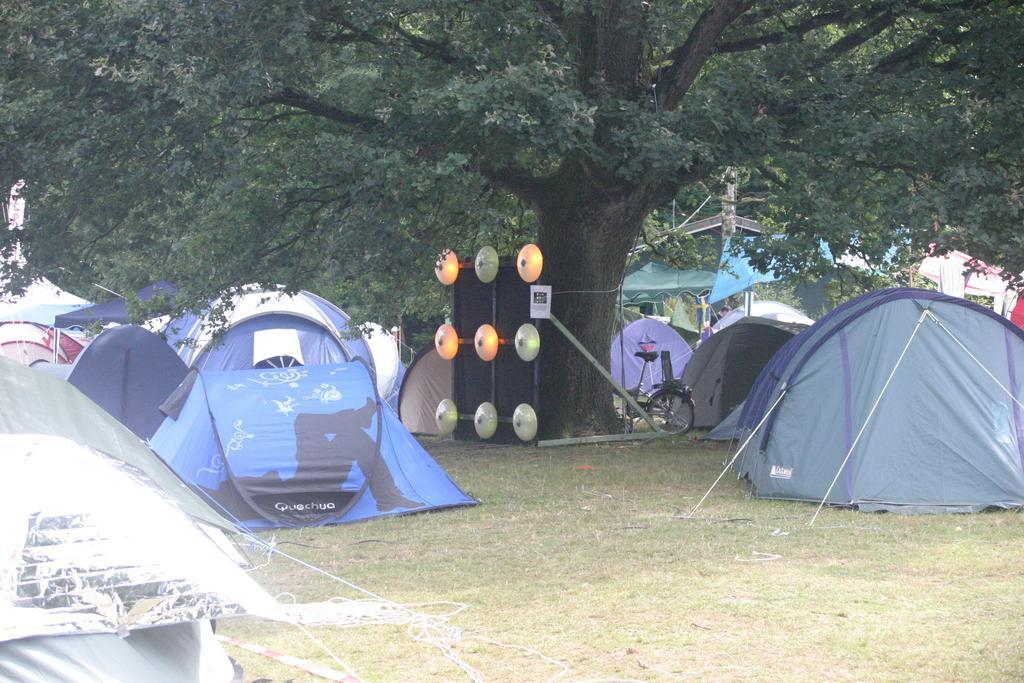Could you give a brief overview of what you see in this image? In this picture I can see tents, there is a bicycle, there are some objects, and in the background there are trees. 